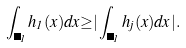Convert formula to latex. <formula><loc_0><loc_0><loc_500><loc_500>\int _ { \Delta _ { 1 } } h _ { 1 } ( x ) d x { \geq } | \int _ { \Delta _ { 1 } } h _ { j } ( x ) d x | .</formula> 